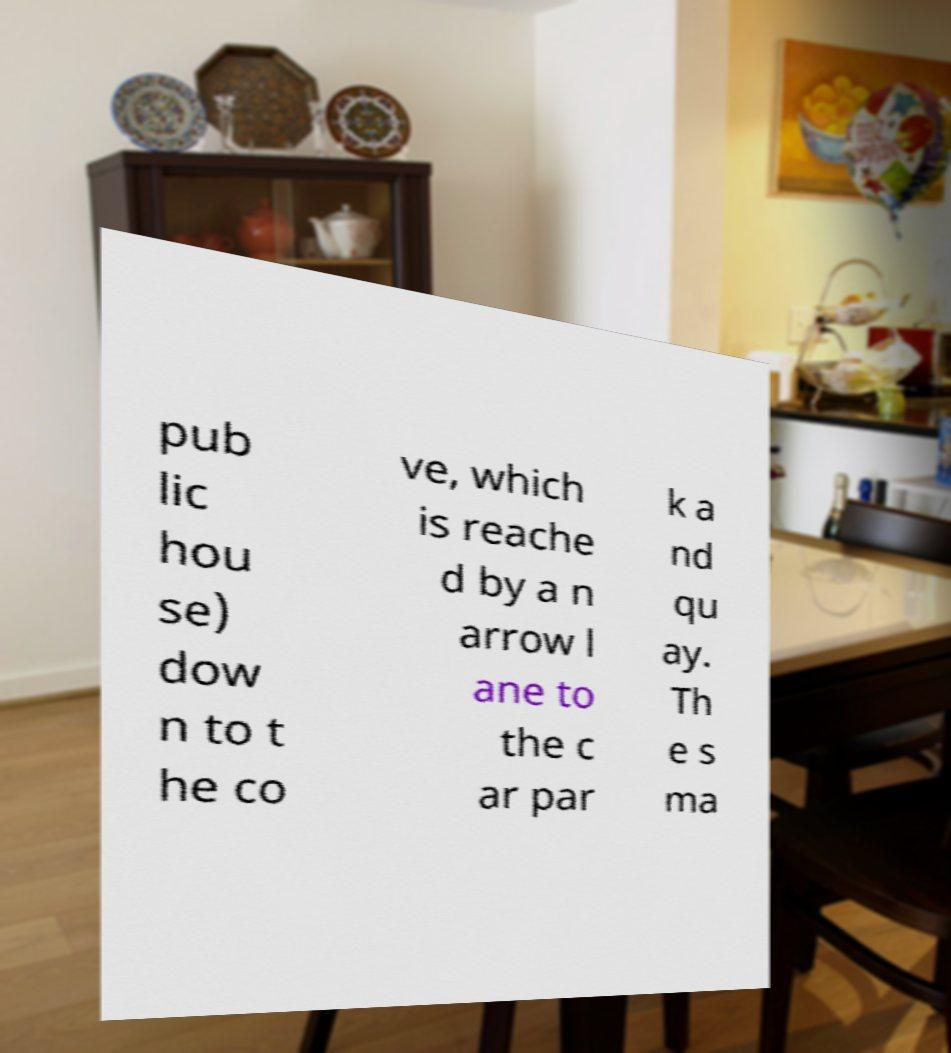Please identify and transcribe the text found in this image. pub lic hou se) dow n to t he co ve, which is reache d by a n arrow l ane to the c ar par k a nd qu ay. Th e s ma 